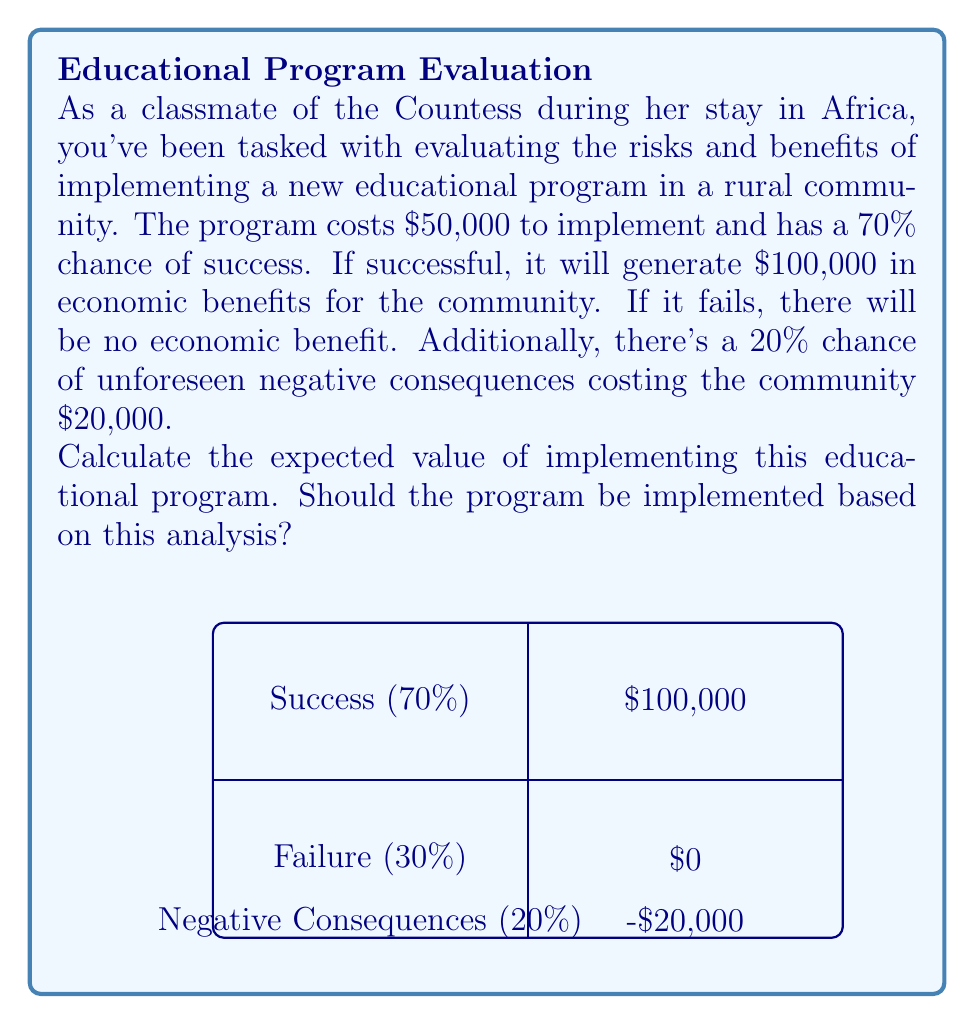Show me your answer to this math problem. Let's approach this problem step-by-step:

1) First, let's calculate the expected value of the program's outcome:
   
   Success: $0.70 \times \$100,000 = \$70,000$
   Failure: $0.30 \times \$0 = \$0$
   
   Expected Value of Outcome: $\$70,000 + \$0 = \$70,000$

2) Now, let's consider the cost of implementation:
   
   Cost: $-\$50,000$

3) Next, we need to account for the potential negative consequences:
   
   Expected Value of Negative Consequences: $0.20 \times (-\$20,000) = -\$4,000$

4) To calculate the total expected value, we sum all these components:

   $$\text{Total Expected Value} = \$70,000 - \$50,000 - \$4,000 = \$16,000$$

5) Since the expected value is positive ($\$16,000 > 0$), implementing the program has a net positive expected outcome.

Therefore, based on this analysis, the program should be implemented as it has a positive expected value of $16,000.
Answer: $16,000; Yes, implement the program 